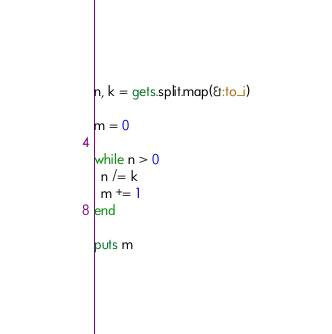<code> <loc_0><loc_0><loc_500><loc_500><_Ruby_>n, k = gets.split.map(&:to_i)

m = 0

while n > 0
  n /= k
  m += 1
end

puts m
</code> 